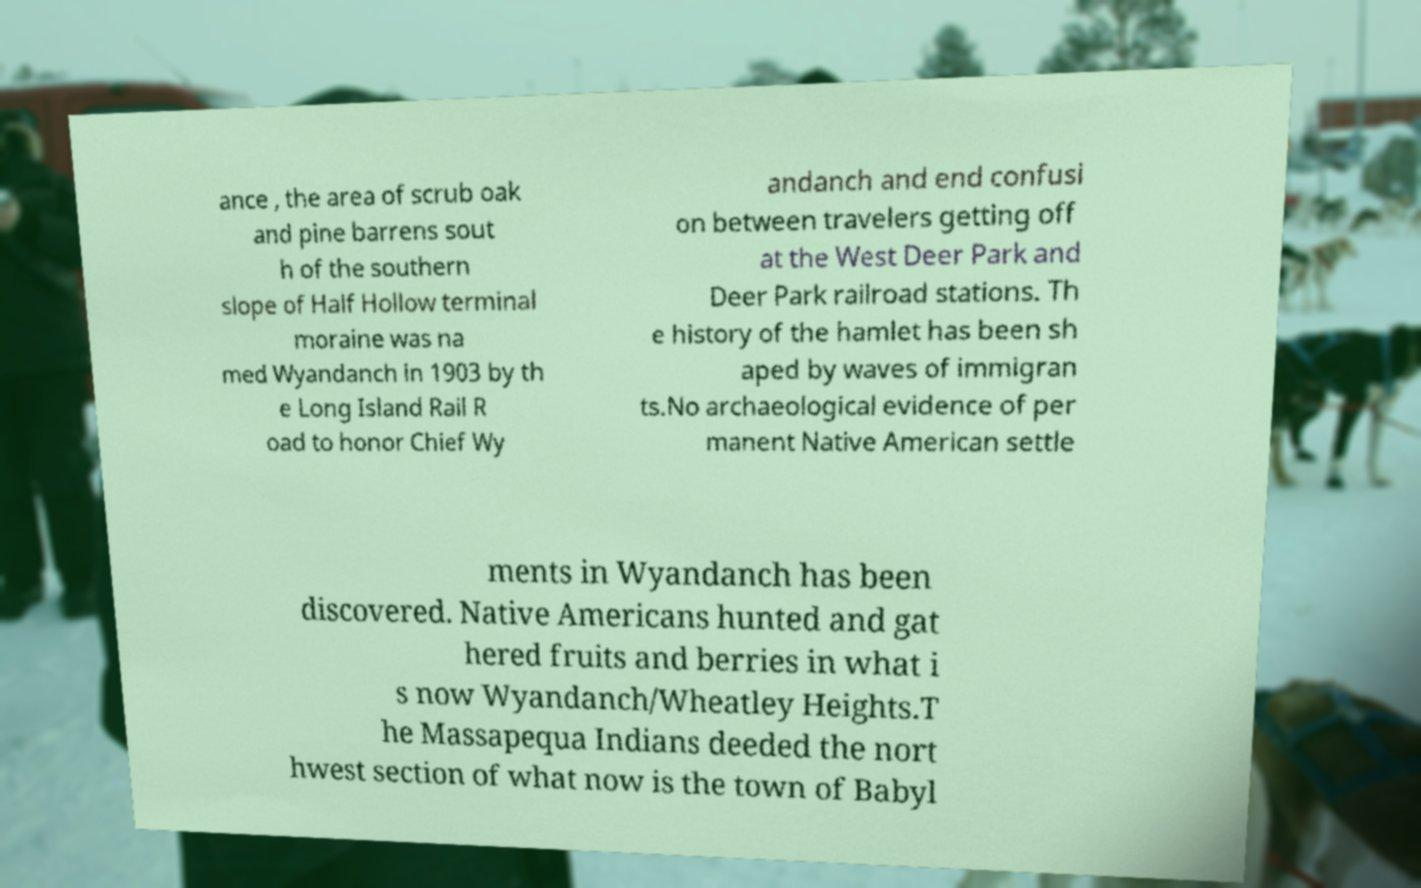There's text embedded in this image that I need extracted. Can you transcribe it verbatim? ance , the area of scrub oak and pine barrens sout h of the southern slope of Half Hollow terminal moraine was na med Wyandanch in 1903 by th e Long Island Rail R oad to honor Chief Wy andanch and end confusi on between travelers getting off at the West Deer Park and Deer Park railroad stations. Th e history of the hamlet has been sh aped by waves of immigran ts.No archaeological evidence of per manent Native American settle ments in Wyandanch has been discovered. Native Americans hunted and gat hered fruits and berries in what i s now Wyandanch/Wheatley Heights.T he Massapequa Indians deeded the nort hwest section of what now is the town of Babyl 